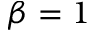<formula> <loc_0><loc_0><loc_500><loc_500>\beta = 1</formula> 